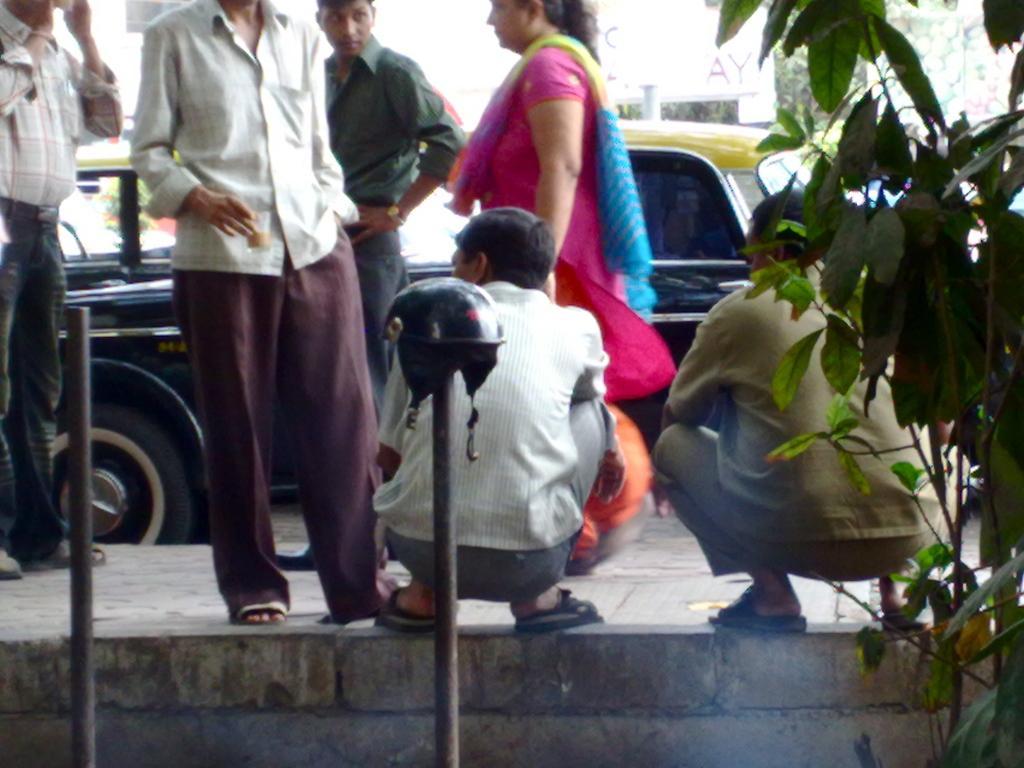Could you give a brief overview of what you see in this image? In this image I can see group of people standing. In front the person is wearing white and brown color dress, background I can see few vehicles, trees in green color and I can also see few poles and the sky is in white color. 